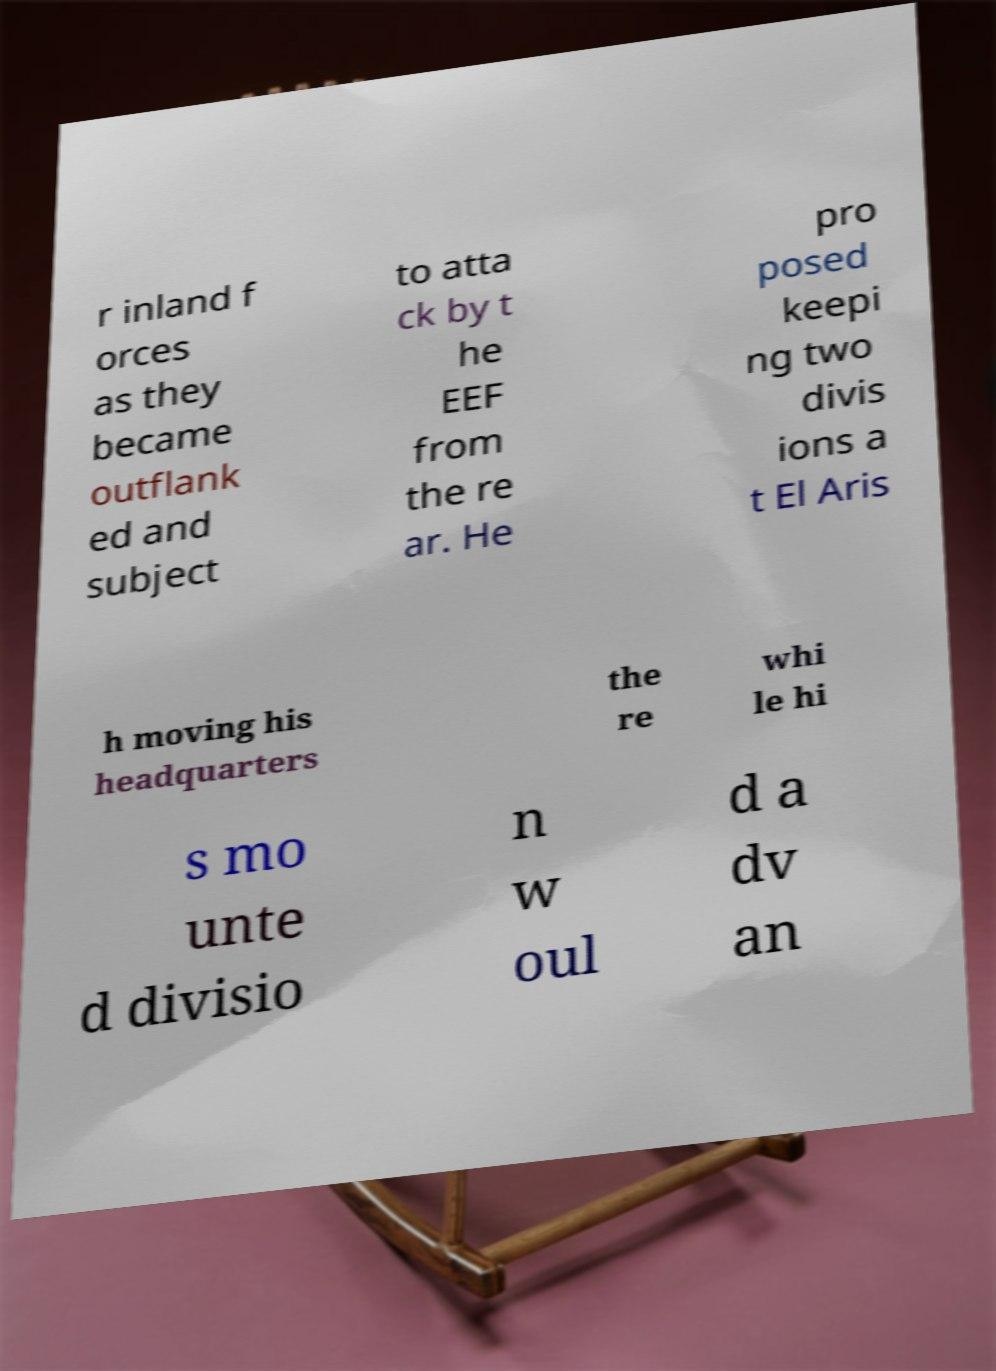Please identify and transcribe the text found in this image. r inland f orces as they became outflank ed and subject to atta ck by t he EEF from the re ar. He pro posed keepi ng two divis ions a t El Aris h moving his headquarters the re whi le hi s mo unte d divisio n w oul d a dv an 